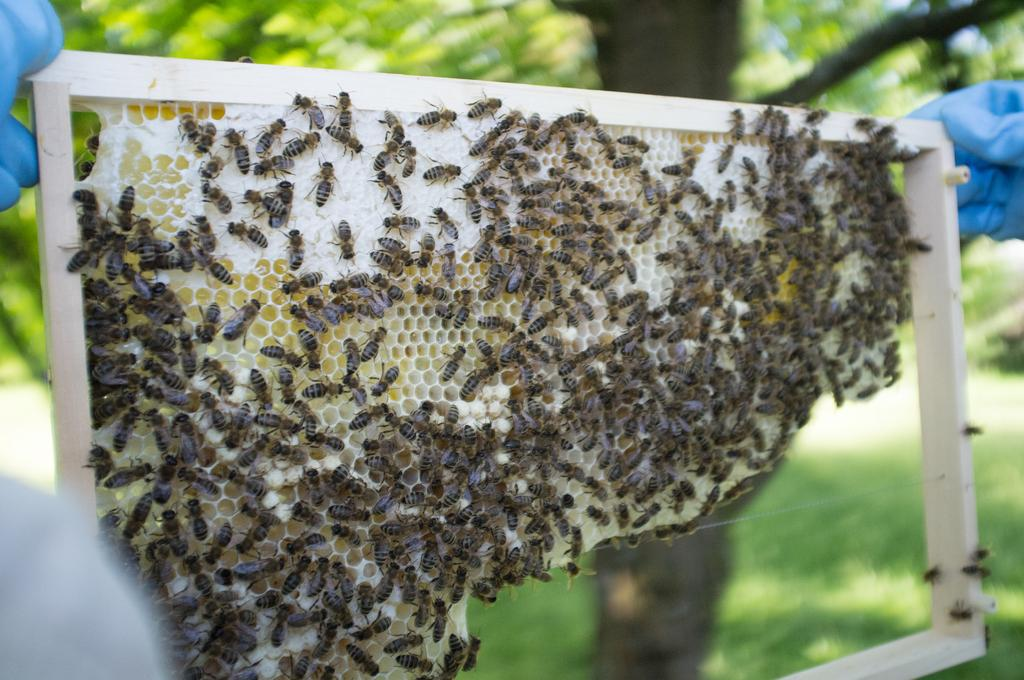Who or what is present in the image? There is a person in the image. What is the person wearing? The person is wearing gloves. What is the person holding? The person is holding a honeycomb. Are there any other creatures visible in the image? Yes, there are bees on the honeycomb. What can be seen in the background of the image? There are trees in the background of the image. What type of lock is used to secure the honeycomb in the image? There is no lock present in the image; the honeycomb is being held by the person. 